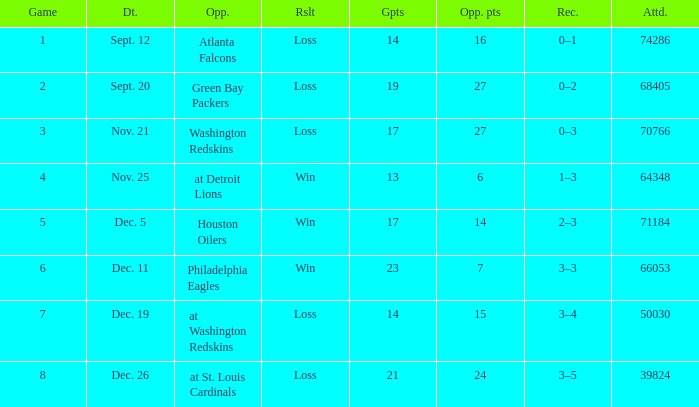What is the record when the opponent is washington redskins? 0–3. 